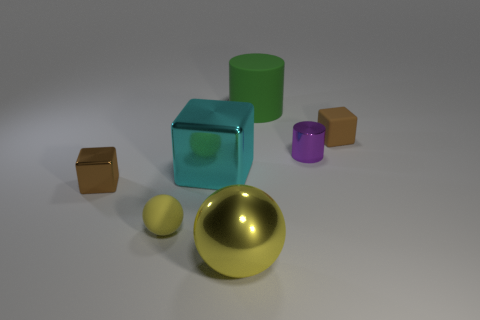Add 3 blue balls. How many objects exist? 10 Subtract all cylinders. How many objects are left? 5 Add 2 small brown cubes. How many small brown cubes are left? 4 Add 2 cyan metal cubes. How many cyan metal cubes exist? 3 Subtract 2 brown cubes. How many objects are left? 5 Subtract all small yellow matte balls. Subtract all large metal objects. How many objects are left? 4 